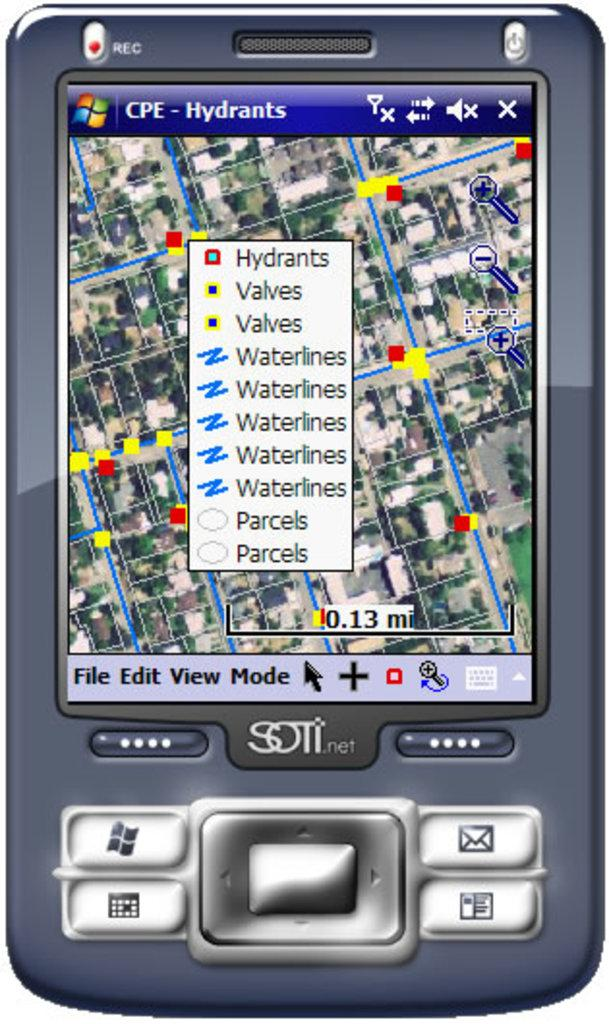Provide a one-sentence caption for the provided image. Screen of a device that says Hydrants on the screen. 